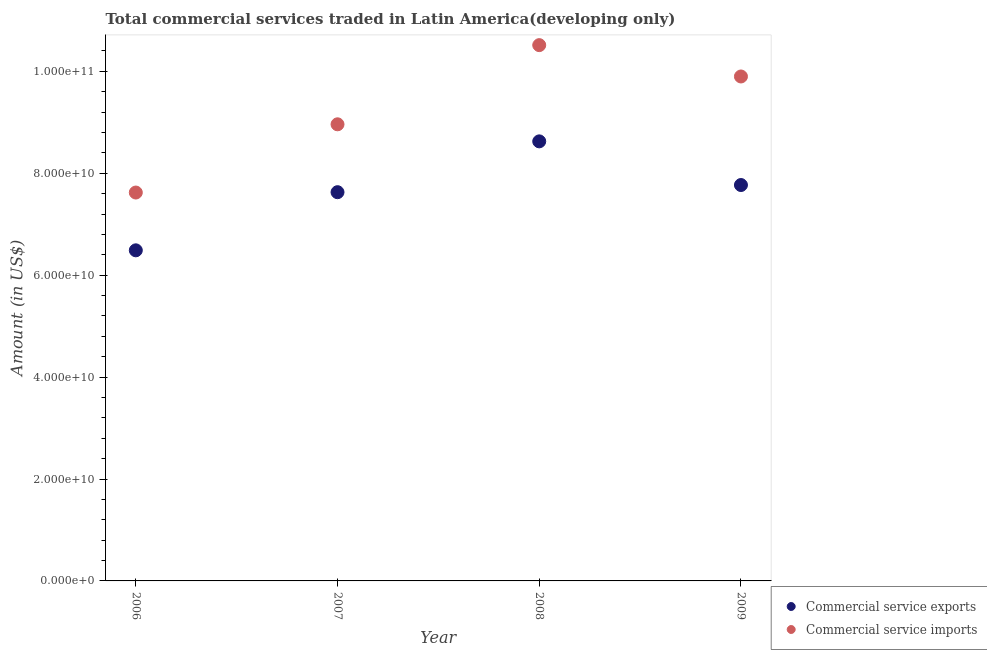Is the number of dotlines equal to the number of legend labels?
Keep it short and to the point. Yes. What is the amount of commercial service imports in 2008?
Ensure brevity in your answer.  1.05e+11. Across all years, what is the maximum amount of commercial service exports?
Your response must be concise. 8.63e+1. Across all years, what is the minimum amount of commercial service imports?
Give a very brief answer. 7.62e+1. What is the total amount of commercial service exports in the graph?
Provide a short and direct response. 3.05e+11. What is the difference between the amount of commercial service imports in 2008 and that in 2009?
Your answer should be very brief. 6.15e+09. What is the difference between the amount of commercial service imports in 2007 and the amount of commercial service exports in 2009?
Your answer should be compact. 1.19e+1. What is the average amount of commercial service imports per year?
Keep it short and to the point. 9.25e+1. In the year 2008, what is the difference between the amount of commercial service imports and amount of commercial service exports?
Offer a terse response. 1.89e+1. In how many years, is the amount of commercial service exports greater than 68000000000 US$?
Offer a terse response. 3. What is the ratio of the amount of commercial service imports in 2008 to that in 2009?
Give a very brief answer. 1.06. Is the difference between the amount of commercial service exports in 2008 and 2009 greater than the difference between the amount of commercial service imports in 2008 and 2009?
Your answer should be very brief. Yes. What is the difference between the highest and the second highest amount of commercial service exports?
Keep it short and to the point. 8.57e+09. What is the difference between the highest and the lowest amount of commercial service exports?
Your response must be concise. 2.14e+1. Is the sum of the amount of commercial service exports in 2007 and 2009 greater than the maximum amount of commercial service imports across all years?
Your answer should be compact. Yes. Is the amount of commercial service imports strictly greater than the amount of commercial service exports over the years?
Your answer should be compact. Yes. Is the amount of commercial service imports strictly less than the amount of commercial service exports over the years?
Ensure brevity in your answer.  No. How many dotlines are there?
Offer a terse response. 2. How many years are there in the graph?
Keep it short and to the point. 4. What is the difference between two consecutive major ticks on the Y-axis?
Keep it short and to the point. 2.00e+1. Are the values on the major ticks of Y-axis written in scientific E-notation?
Give a very brief answer. Yes. Does the graph contain grids?
Your answer should be very brief. No. Where does the legend appear in the graph?
Give a very brief answer. Bottom right. How many legend labels are there?
Your answer should be compact. 2. How are the legend labels stacked?
Provide a short and direct response. Vertical. What is the title of the graph?
Offer a terse response. Total commercial services traded in Latin America(developing only). Does "Netherlands" appear as one of the legend labels in the graph?
Keep it short and to the point. No. What is the label or title of the Y-axis?
Offer a terse response. Amount (in US$). What is the Amount (in US$) in Commercial service exports in 2006?
Offer a terse response. 6.49e+1. What is the Amount (in US$) in Commercial service imports in 2006?
Provide a succinct answer. 7.62e+1. What is the Amount (in US$) in Commercial service exports in 2007?
Provide a short and direct response. 7.63e+1. What is the Amount (in US$) in Commercial service imports in 2007?
Provide a succinct answer. 8.96e+1. What is the Amount (in US$) in Commercial service exports in 2008?
Your answer should be very brief. 8.63e+1. What is the Amount (in US$) in Commercial service imports in 2008?
Your answer should be compact. 1.05e+11. What is the Amount (in US$) of Commercial service exports in 2009?
Keep it short and to the point. 7.77e+1. What is the Amount (in US$) in Commercial service imports in 2009?
Offer a terse response. 9.90e+1. Across all years, what is the maximum Amount (in US$) of Commercial service exports?
Offer a terse response. 8.63e+1. Across all years, what is the maximum Amount (in US$) of Commercial service imports?
Keep it short and to the point. 1.05e+11. Across all years, what is the minimum Amount (in US$) in Commercial service exports?
Give a very brief answer. 6.49e+1. Across all years, what is the minimum Amount (in US$) in Commercial service imports?
Make the answer very short. 7.62e+1. What is the total Amount (in US$) of Commercial service exports in the graph?
Provide a succinct answer. 3.05e+11. What is the total Amount (in US$) in Commercial service imports in the graph?
Your answer should be very brief. 3.70e+11. What is the difference between the Amount (in US$) of Commercial service exports in 2006 and that in 2007?
Give a very brief answer. -1.14e+1. What is the difference between the Amount (in US$) in Commercial service imports in 2006 and that in 2007?
Provide a short and direct response. -1.34e+1. What is the difference between the Amount (in US$) of Commercial service exports in 2006 and that in 2008?
Provide a short and direct response. -2.14e+1. What is the difference between the Amount (in US$) in Commercial service imports in 2006 and that in 2008?
Your answer should be compact. -2.89e+1. What is the difference between the Amount (in US$) in Commercial service exports in 2006 and that in 2009?
Provide a short and direct response. -1.28e+1. What is the difference between the Amount (in US$) of Commercial service imports in 2006 and that in 2009?
Provide a short and direct response. -2.28e+1. What is the difference between the Amount (in US$) of Commercial service exports in 2007 and that in 2008?
Your answer should be very brief. -9.97e+09. What is the difference between the Amount (in US$) in Commercial service imports in 2007 and that in 2008?
Ensure brevity in your answer.  -1.55e+1. What is the difference between the Amount (in US$) in Commercial service exports in 2007 and that in 2009?
Your answer should be very brief. -1.41e+09. What is the difference between the Amount (in US$) of Commercial service imports in 2007 and that in 2009?
Ensure brevity in your answer.  -9.38e+09. What is the difference between the Amount (in US$) in Commercial service exports in 2008 and that in 2009?
Your answer should be compact. 8.57e+09. What is the difference between the Amount (in US$) of Commercial service imports in 2008 and that in 2009?
Offer a very short reply. 6.15e+09. What is the difference between the Amount (in US$) of Commercial service exports in 2006 and the Amount (in US$) of Commercial service imports in 2007?
Make the answer very short. -2.47e+1. What is the difference between the Amount (in US$) in Commercial service exports in 2006 and the Amount (in US$) in Commercial service imports in 2008?
Your answer should be very brief. -4.03e+1. What is the difference between the Amount (in US$) of Commercial service exports in 2006 and the Amount (in US$) of Commercial service imports in 2009?
Give a very brief answer. -3.41e+1. What is the difference between the Amount (in US$) in Commercial service exports in 2007 and the Amount (in US$) in Commercial service imports in 2008?
Offer a very short reply. -2.89e+1. What is the difference between the Amount (in US$) in Commercial service exports in 2007 and the Amount (in US$) in Commercial service imports in 2009?
Offer a terse response. -2.27e+1. What is the difference between the Amount (in US$) of Commercial service exports in 2008 and the Amount (in US$) of Commercial service imports in 2009?
Keep it short and to the point. -1.27e+1. What is the average Amount (in US$) of Commercial service exports per year?
Provide a short and direct response. 7.63e+1. What is the average Amount (in US$) in Commercial service imports per year?
Make the answer very short. 9.25e+1. In the year 2006, what is the difference between the Amount (in US$) in Commercial service exports and Amount (in US$) in Commercial service imports?
Your answer should be compact. -1.13e+1. In the year 2007, what is the difference between the Amount (in US$) in Commercial service exports and Amount (in US$) in Commercial service imports?
Give a very brief answer. -1.33e+1. In the year 2008, what is the difference between the Amount (in US$) in Commercial service exports and Amount (in US$) in Commercial service imports?
Your answer should be compact. -1.89e+1. In the year 2009, what is the difference between the Amount (in US$) of Commercial service exports and Amount (in US$) of Commercial service imports?
Your answer should be very brief. -2.13e+1. What is the ratio of the Amount (in US$) in Commercial service exports in 2006 to that in 2007?
Ensure brevity in your answer.  0.85. What is the ratio of the Amount (in US$) in Commercial service imports in 2006 to that in 2007?
Provide a succinct answer. 0.85. What is the ratio of the Amount (in US$) of Commercial service exports in 2006 to that in 2008?
Provide a succinct answer. 0.75. What is the ratio of the Amount (in US$) of Commercial service imports in 2006 to that in 2008?
Offer a very short reply. 0.72. What is the ratio of the Amount (in US$) in Commercial service exports in 2006 to that in 2009?
Provide a succinct answer. 0.83. What is the ratio of the Amount (in US$) in Commercial service imports in 2006 to that in 2009?
Offer a very short reply. 0.77. What is the ratio of the Amount (in US$) in Commercial service exports in 2007 to that in 2008?
Offer a very short reply. 0.88. What is the ratio of the Amount (in US$) of Commercial service imports in 2007 to that in 2008?
Your response must be concise. 0.85. What is the ratio of the Amount (in US$) of Commercial service exports in 2007 to that in 2009?
Your answer should be compact. 0.98. What is the ratio of the Amount (in US$) in Commercial service imports in 2007 to that in 2009?
Make the answer very short. 0.91. What is the ratio of the Amount (in US$) in Commercial service exports in 2008 to that in 2009?
Make the answer very short. 1.11. What is the ratio of the Amount (in US$) in Commercial service imports in 2008 to that in 2009?
Provide a short and direct response. 1.06. What is the difference between the highest and the second highest Amount (in US$) in Commercial service exports?
Provide a succinct answer. 8.57e+09. What is the difference between the highest and the second highest Amount (in US$) in Commercial service imports?
Ensure brevity in your answer.  6.15e+09. What is the difference between the highest and the lowest Amount (in US$) in Commercial service exports?
Your answer should be very brief. 2.14e+1. What is the difference between the highest and the lowest Amount (in US$) of Commercial service imports?
Your response must be concise. 2.89e+1. 